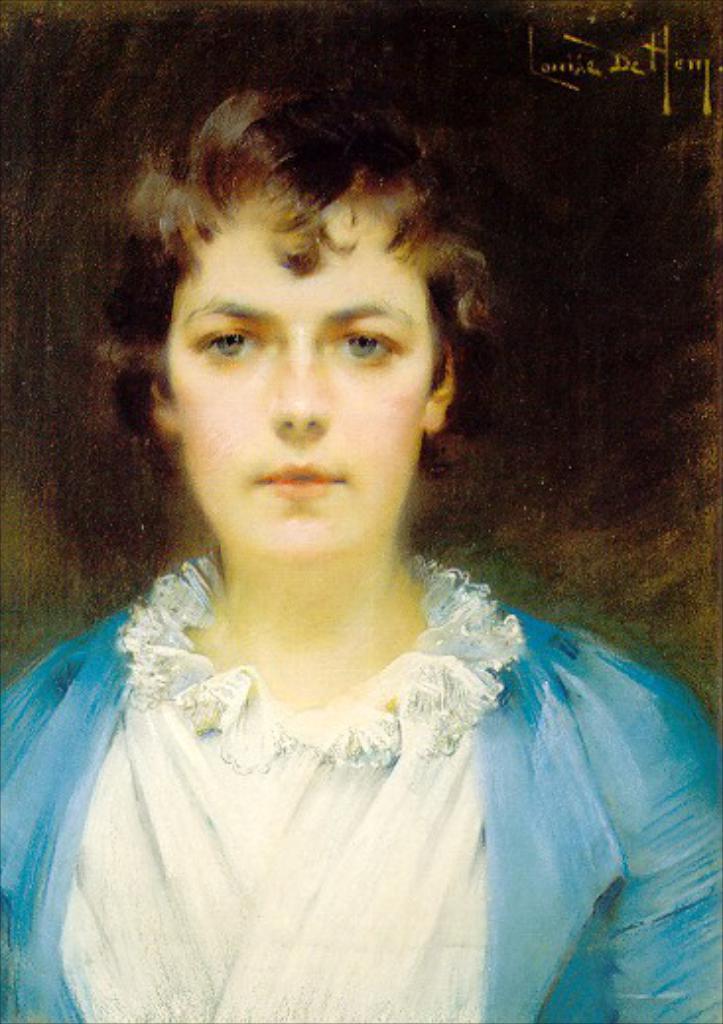How would you summarize this image in a sentence or two? In this picture we can see painting of a woman on the board. 